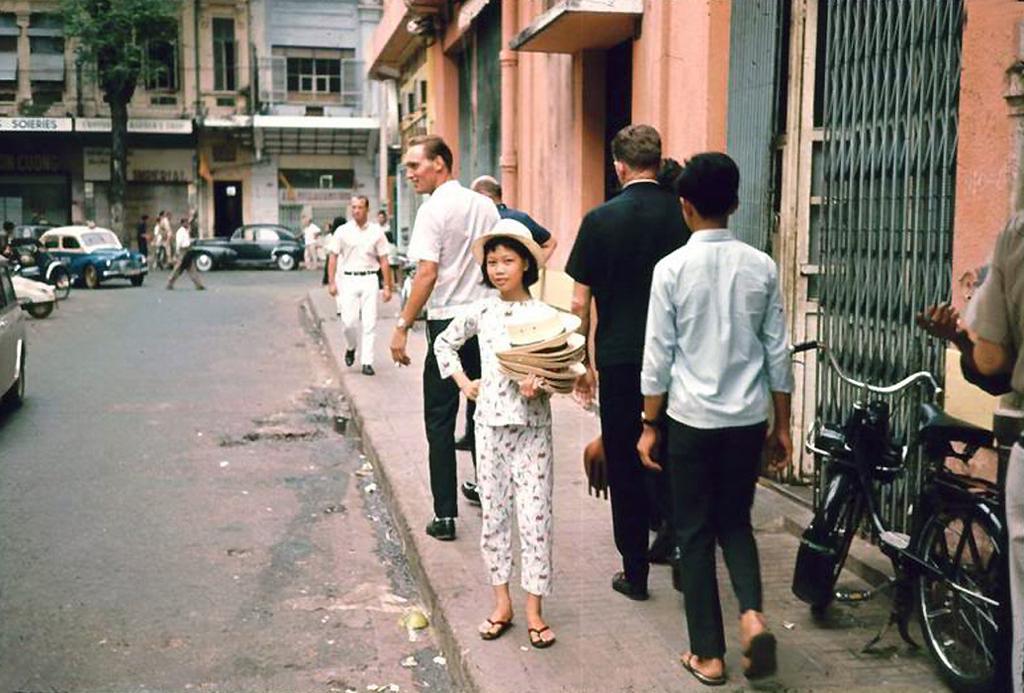Describe this image in one or two sentences. In this picture we can see a group of people on the footpath, vehicles, some people on the road, tree, some objects and in the background we can see buildings with windows. 